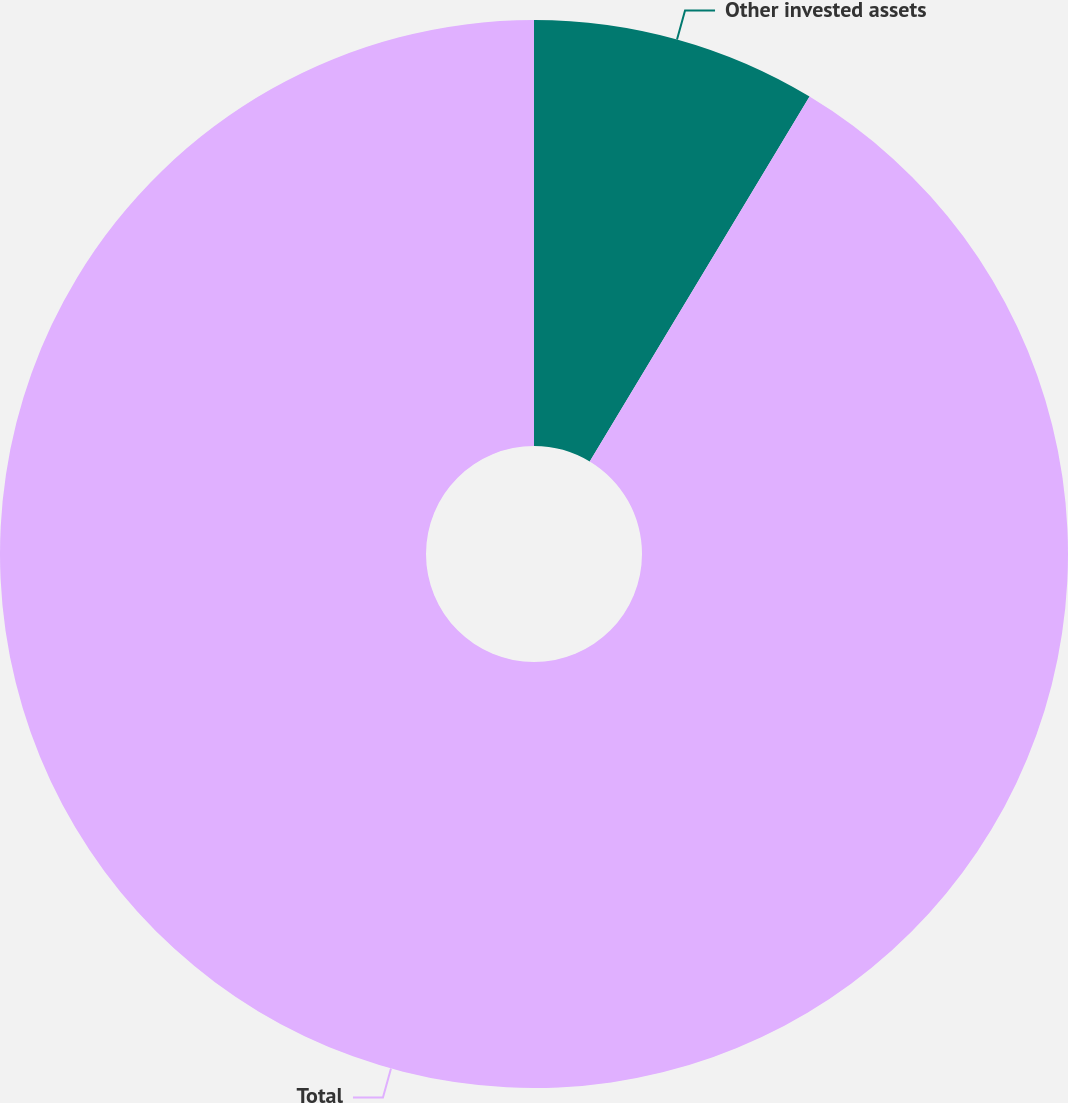Convert chart to OTSL. <chart><loc_0><loc_0><loc_500><loc_500><pie_chart><fcel>Other invested assets<fcel>Total<nl><fcel>8.63%<fcel>91.37%<nl></chart> 